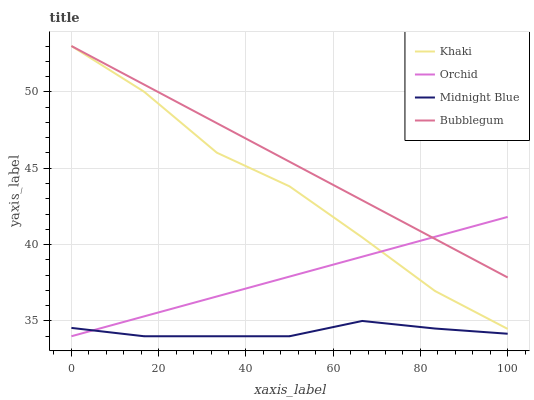Does Midnight Blue have the minimum area under the curve?
Answer yes or no. Yes. Does Bubblegum have the maximum area under the curve?
Answer yes or no. Yes. Does Bubblegum have the minimum area under the curve?
Answer yes or no. No. Does Midnight Blue have the maximum area under the curve?
Answer yes or no. No. Is Bubblegum the smoothest?
Answer yes or no. Yes. Is Khaki the roughest?
Answer yes or no. Yes. Is Midnight Blue the smoothest?
Answer yes or no. No. Is Midnight Blue the roughest?
Answer yes or no. No. Does Bubblegum have the lowest value?
Answer yes or no. No. Does Bubblegum have the highest value?
Answer yes or no. Yes. Does Midnight Blue have the highest value?
Answer yes or no. No. Is Midnight Blue less than Bubblegum?
Answer yes or no. Yes. Is Bubblegum greater than Midnight Blue?
Answer yes or no. Yes. Does Midnight Blue intersect Bubblegum?
Answer yes or no. No. 